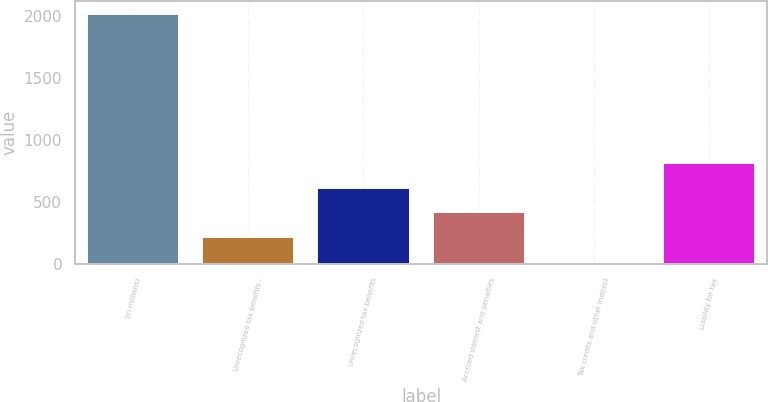Convert chart. <chart><loc_0><loc_0><loc_500><loc_500><bar_chart><fcel>(in millions)<fcel>Unrecognized tax benefits -<fcel>Unrecognized tax benefits<fcel>Accrued interest and penalties<fcel>Tax credits and other indirect<fcel>Liability for tax<nl><fcel>2014<fcel>216.7<fcel>616.1<fcel>416.4<fcel>17<fcel>815.8<nl></chart> 